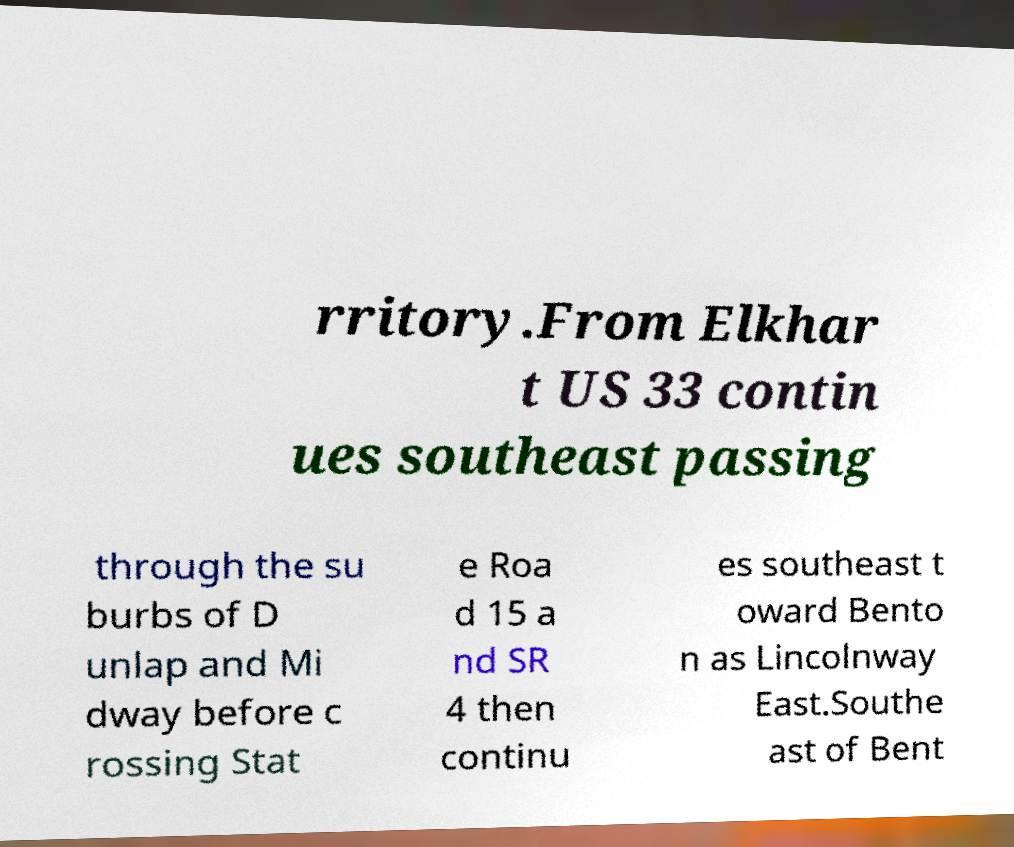Could you extract and type out the text from this image? rritory.From Elkhar t US 33 contin ues southeast passing through the su burbs of D unlap and Mi dway before c rossing Stat e Roa d 15 a nd SR 4 then continu es southeast t oward Bento n as Lincolnway East.Southe ast of Bent 